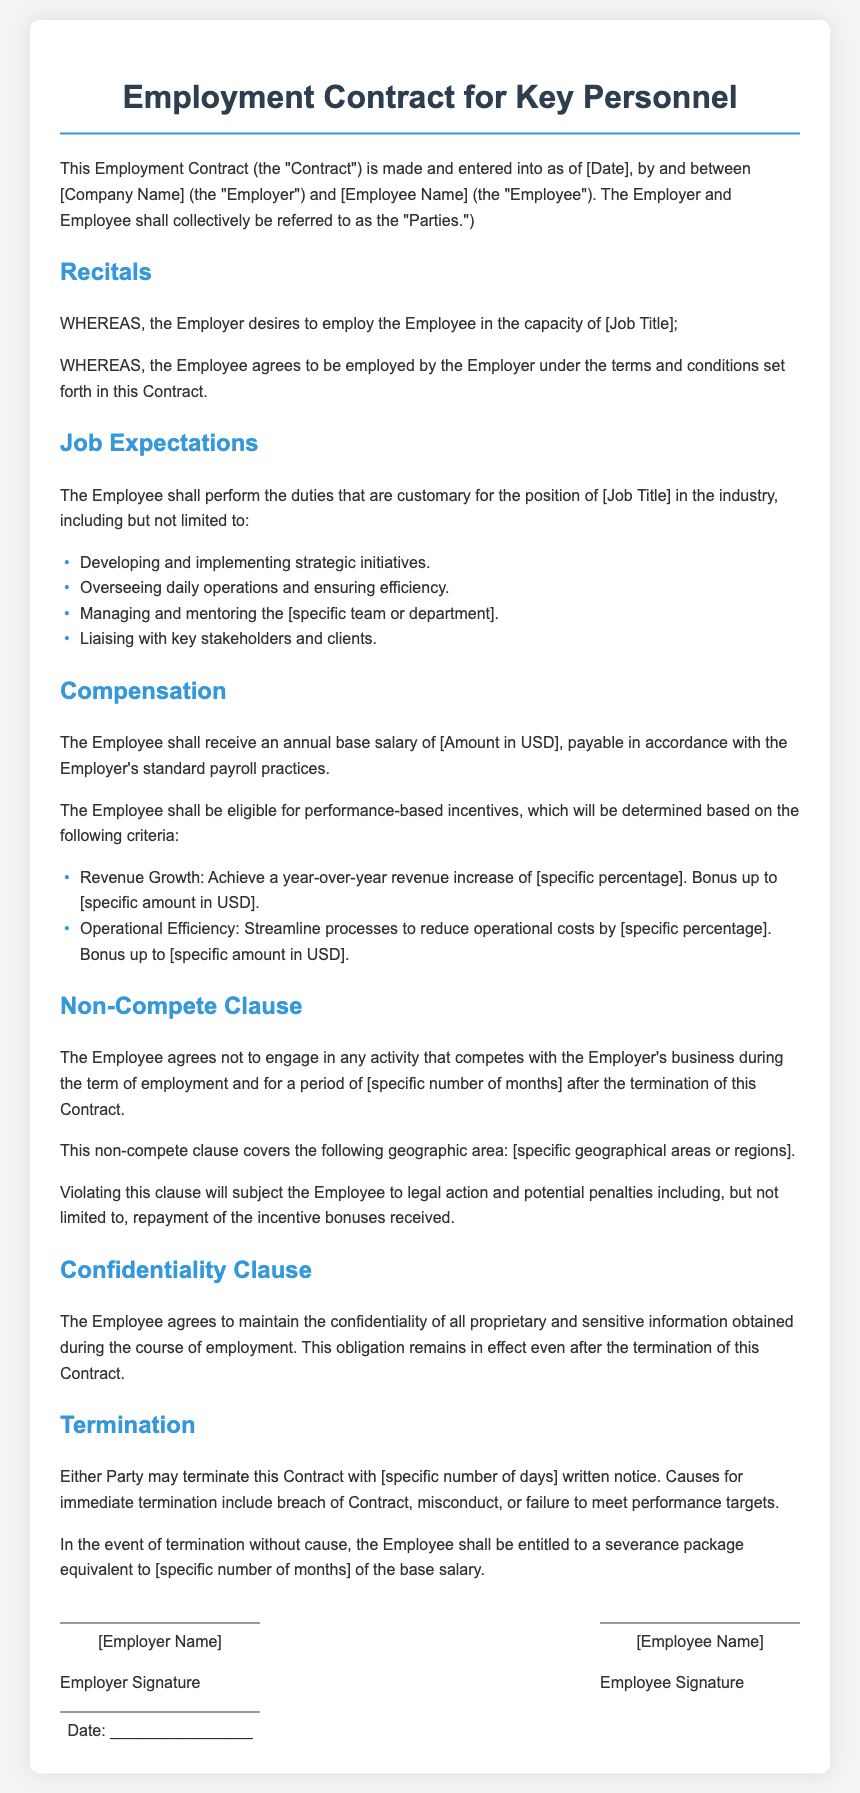What is the title of the document? The title of the document is indicated at the top of the rendered contract.
Answer: Employment Contract for Key Personnel Who is the Employee? The document requires filling in the specific name of the employee.
Answer: [Employee Name] What is the annual base salary? The document specifies the amount as part of the compensation section.
Answer: [Amount in USD] What is the required notice period for termination? The notice period is mentioned in the termination section of the document.
Answer: [specific number of days] How long is the non-compete period? The duration of the non-compete clause is specified in the contract details.
Answer: [specific number of months] What is one criterion for performance-based incentives? The criteria for performance-based incentives are listed in the compensation section.
Answer: Revenue Growth What happens if the non-compete clause is violated? The consequences of violating the non-compete clause are explicitly stated in the document.
Answer: Legal action What must the Employee maintain confidentiality about? The confidentiality obligations of the Employee are explained in the confidentiality clause.
Answer: Proprietary and sensitive information Who must sign the contract? The signatures section indicates who must sign the document.
Answer: Employer and Employee 